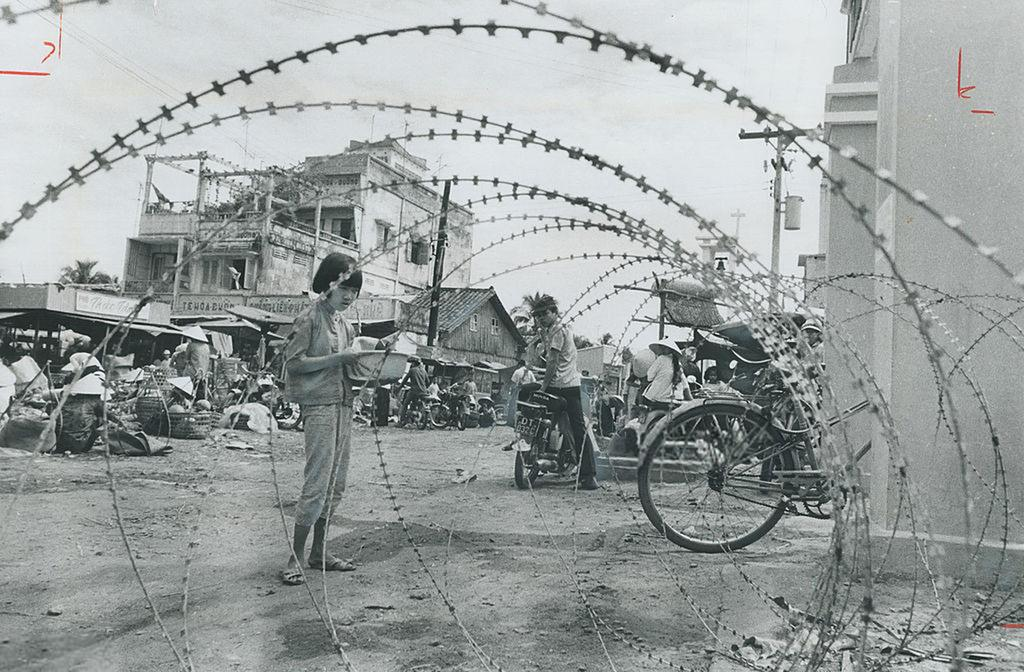Who or what can be seen in the image? There are people in the image. What type of vehicles are present in the image? Motorcycles are present in the image. What other mode of transportation can be seen on the ground? A bicycle is visible on the ground. What type of structures are visible in the image? There are buildings in the image. What tall structures can be seen in the image? Electric poles are present in the image. Are there any unidentified objects in the image? Yes, there are some unspecified objects in the image. What can be seen in the background of the image? The sky is visible in the background of the image. Can you tell me how many faces are visible on the donkey in the image? There is no donkey present in the image, so it is not possible to determine the number of faces on it. 